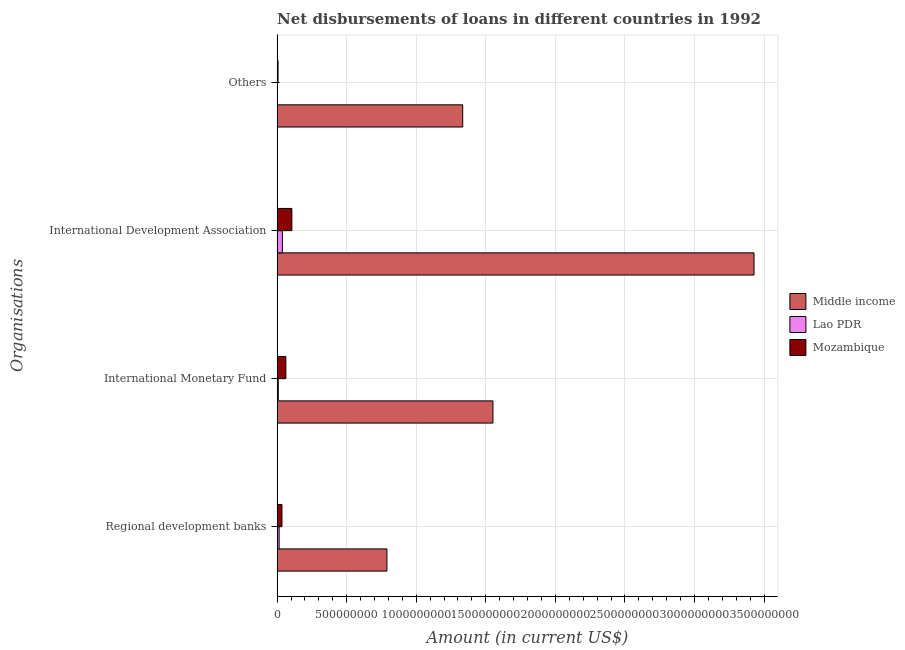How many different coloured bars are there?
Give a very brief answer. 3. How many groups of bars are there?
Make the answer very short. 4. Are the number of bars per tick equal to the number of legend labels?
Offer a terse response. No. Are the number of bars on each tick of the Y-axis equal?
Keep it short and to the point. No. How many bars are there on the 1st tick from the top?
Keep it short and to the point. 2. What is the label of the 2nd group of bars from the top?
Make the answer very short. International Development Association. What is the amount of loan disimbursed by other organisations in Lao PDR?
Offer a terse response. 0. Across all countries, what is the maximum amount of loan disimbursed by international monetary fund?
Ensure brevity in your answer.  1.55e+09. Across all countries, what is the minimum amount of loan disimbursed by international monetary fund?
Offer a terse response. 8.25e+06. What is the total amount of loan disimbursed by international development association in the graph?
Make the answer very short. 3.57e+09. What is the difference between the amount of loan disimbursed by international development association in Lao PDR and that in Mozambique?
Provide a short and direct response. -6.82e+07. What is the difference between the amount of loan disimbursed by regional development banks in Lao PDR and the amount of loan disimbursed by other organisations in Middle income?
Keep it short and to the point. -1.32e+09. What is the average amount of loan disimbursed by regional development banks per country?
Make the answer very short. 2.80e+08. What is the difference between the amount of loan disimbursed by regional development banks and amount of loan disimbursed by international development association in Lao PDR?
Your response must be concise. -2.32e+07. What is the ratio of the amount of loan disimbursed by other organisations in Middle income to that in Mozambique?
Offer a terse response. 203.04. What is the difference between the highest and the second highest amount of loan disimbursed by international development association?
Your response must be concise. 3.32e+09. What is the difference between the highest and the lowest amount of loan disimbursed by international monetary fund?
Offer a very short reply. 1.54e+09. Is it the case that in every country, the sum of the amount of loan disimbursed by regional development banks and amount of loan disimbursed by other organisations is greater than the sum of amount of loan disimbursed by international development association and amount of loan disimbursed by international monetary fund?
Provide a succinct answer. No. How many countries are there in the graph?
Make the answer very short. 3. Are the values on the major ticks of X-axis written in scientific E-notation?
Your answer should be very brief. No. Does the graph contain grids?
Provide a short and direct response. Yes. Where does the legend appear in the graph?
Provide a short and direct response. Center right. How many legend labels are there?
Your response must be concise. 3. How are the legend labels stacked?
Ensure brevity in your answer.  Vertical. What is the title of the graph?
Your answer should be compact. Net disbursements of loans in different countries in 1992. Does "Northern Mariana Islands" appear as one of the legend labels in the graph?
Provide a short and direct response. No. What is the label or title of the X-axis?
Ensure brevity in your answer.  Amount (in current US$). What is the label or title of the Y-axis?
Your answer should be compact. Organisations. What is the Amount (in current US$) of Middle income in Regional development banks?
Keep it short and to the point. 7.89e+08. What is the Amount (in current US$) in Lao PDR in Regional development banks?
Your answer should be compact. 1.45e+07. What is the Amount (in current US$) in Mozambique in Regional development banks?
Your answer should be compact. 3.48e+07. What is the Amount (in current US$) in Middle income in International Monetary Fund?
Your answer should be compact. 1.55e+09. What is the Amount (in current US$) of Lao PDR in International Monetary Fund?
Give a very brief answer. 8.25e+06. What is the Amount (in current US$) of Mozambique in International Monetary Fund?
Keep it short and to the point. 6.27e+07. What is the Amount (in current US$) of Middle income in International Development Association?
Give a very brief answer. 3.43e+09. What is the Amount (in current US$) in Lao PDR in International Development Association?
Provide a short and direct response. 3.77e+07. What is the Amount (in current US$) of Mozambique in International Development Association?
Your answer should be very brief. 1.06e+08. What is the Amount (in current US$) in Middle income in Others?
Provide a short and direct response. 1.33e+09. What is the Amount (in current US$) in Mozambique in Others?
Offer a terse response. 6.57e+06. Across all Organisations, what is the maximum Amount (in current US$) of Middle income?
Keep it short and to the point. 3.43e+09. Across all Organisations, what is the maximum Amount (in current US$) of Lao PDR?
Your response must be concise. 3.77e+07. Across all Organisations, what is the maximum Amount (in current US$) of Mozambique?
Your answer should be compact. 1.06e+08. Across all Organisations, what is the minimum Amount (in current US$) of Middle income?
Offer a terse response. 7.89e+08. Across all Organisations, what is the minimum Amount (in current US$) of Mozambique?
Ensure brevity in your answer.  6.57e+06. What is the total Amount (in current US$) of Middle income in the graph?
Give a very brief answer. 7.10e+09. What is the total Amount (in current US$) of Lao PDR in the graph?
Your response must be concise. 6.05e+07. What is the total Amount (in current US$) in Mozambique in the graph?
Your response must be concise. 2.10e+08. What is the difference between the Amount (in current US$) of Middle income in Regional development banks and that in International Monetary Fund?
Keep it short and to the point. -7.62e+08. What is the difference between the Amount (in current US$) in Lao PDR in Regional development banks and that in International Monetary Fund?
Offer a very short reply. 6.28e+06. What is the difference between the Amount (in current US$) in Mozambique in Regional development banks and that in International Monetary Fund?
Offer a terse response. -2.79e+07. What is the difference between the Amount (in current US$) of Middle income in Regional development banks and that in International Development Association?
Keep it short and to the point. -2.64e+09. What is the difference between the Amount (in current US$) in Lao PDR in Regional development banks and that in International Development Association?
Keep it short and to the point. -2.32e+07. What is the difference between the Amount (in current US$) in Mozambique in Regional development banks and that in International Development Association?
Ensure brevity in your answer.  -7.11e+07. What is the difference between the Amount (in current US$) of Middle income in Regional development banks and that in Others?
Ensure brevity in your answer.  -5.45e+08. What is the difference between the Amount (in current US$) in Mozambique in Regional development banks and that in Others?
Ensure brevity in your answer.  2.82e+07. What is the difference between the Amount (in current US$) of Middle income in International Monetary Fund and that in International Development Association?
Your answer should be very brief. -1.88e+09. What is the difference between the Amount (in current US$) of Lao PDR in International Monetary Fund and that in International Development Association?
Your answer should be very brief. -2.94e+07. What is the difference between the Amount (in current US$) in Mozambique in International Monetary Fund and that in International Development Association?
Your answer should be compact. -4.32e+07. What is the difference between the Amount (in current US$) of Middle income in International Monetary Fund and that in Others?
Your answer should be compact. 2.17e+08. What is the difference between the Amount (in current US$) of Mozambique in International Monetary Fund and that in Others?
Offer a very short reply. 5.62e+07. What is the difference between the Amount (in current US$) in Middle income in International Development Association and that in Others?
Provide a short and direct response. 2.09e+09. What is the difference between the Amount (in current US$) in Mozambique in International Development Association and that in Others?
Offer a terse response. 9.94e+07. What is the difference between the Amount (in current US$) of Middle income in Regional development banks and the Amount (in current US$) of Lao PDR in International Monetary Fund?
Make the answer very short. 7.81e+08. What is the difference between the Amount (in current US$) of Middle income in Regional development banks and the Amount (in current US$) of Mozambique in International Monetary Fund?
Your answer should be compact. 7.26e+08. What is the difference between the Amount (in current US$) of Lao PDR in Regional development banks and the Amount (in current US$) of Mozambique in International Monetary Fund?
Ensure brevity in your answer.  -4.82e+07. What is the difference between the Amount (in current US$) in Middle income in Regional development banks and the Amount (in current US$) in Lao PDR in International Development Association?
Your answer should be very brief. 7.51e+08. What is the difference between the Amount (in current US$) in Middle income in Regional development banks and the Amount (in current US$) in Mozambique in International Development Association?
Offer a very short reply. 6.83e+08. What is the difference between the Amount (in current US$) of Lao PDR in Regional development banks and the Amount (in current US$) of Mozambique in International Development Association?
Your response must be concise. -9.14e+07. What is the difference between the Amount (in current US$) of Middle income in Regional development banks and the Amount (in current US$) of Mozambique in Others?
Your answer should be compact. 7.83e+08. What is the difference between the Amount (in current US$) in Lao PDR in Regional development banks and the Amount (in current US$) in Mozambique in Others?
Provide a short and direct response. 7.96e+06. What is the difference between the Amount (in current US$) in Middle income in International Monetary Fund and the Amount (in current US$) in Lao PDR in International Development Association?
Your answer should be compact. 1.51e+09. What is the difference between the Amount (in current US$) in Middle income in International Monetary Fund and the Amount (in current US$) in Mozambique in International Development Association?
Provide a succinct answer. 1.45e+09. What is the difference between the Amount (in current US$) of Lao PDR in International Monetary Fund and the Amount (in current US$) of Mozambique in International Development Association?
Your answer should be very brief. -9.77e+07. What is the difference between the Amount (in current US$) of Middle income in International Monetary Fund and the Amount (in current US$) of Mozambique in Others?
Keep it short and to the point. 1.54e+09. What is the difference between the Amount (in current US$) of Lao PDR in International Monetary Fund and the Amount (in current US$) of Mozambique in Others?
Provide a succinct answer. 1.68e+06. What is the difference between the Amount (in current US$) of Middle income in International Development Association and the Amount (in current US$) of Mozambique in Others?
Offer a very short reply. 3.42e+09. What is the difference between the Amount (in current US$) in Lao PDR in International Development Association and the Amount (in current US$) in Mozambique in Others?
Your response must be concise. 3.11e+07. What is the average Amount (in current US$) in Middle income per Organisations?
Your answer should be compact. 1.78e+09. What is the average Amount (in current US$) of Lao PDR per Organisations?
Keep it short and to the point. 1.51e+07. What is the average Amount (in current US$) of Mozambique per Organisations?
Your answer should be very brief. 5.25e+07. What is the difference between the Amount (in current US$) of Middle income and Amount (in current US$) of Lao PDR in Regional development banks?
Your answer should be very brief. 7.75e+08. What is the difference between the Amount (in current US$) of Middle income and Amount (in current US$) of Mozambique in Regional development banks?
Your answer should be compact. 7.54e+08. What is the difference between the Amount (in current US$) in Lao PDR and Amount (in current US$) in Mozambique in Regional development banks?
Make the answer very short. -2.03e+07. What is the difference between the Amount (in current US$) in Middle income and Amount (in current US$) in Lao PDR in International Monetary Fund?
Your answer should be very brief. 1.54e+09. What is the difference between the Amount (in current US$) in Middle income and Amount (in current US$) in Mozambique in International Monetary Fund?
Make the answer very short. 1.49e+09. What is the difference between the Amount (in current US$) in Lao PDR and Amount (in current US$) in Mozambique in International Monetary Fund?
Offer a very short reply. -5.45e+07. What is the difference between the Amount (in current US$) of Middle income and Amount (in current US$) of Lao PDR in International Development Association?
Offer a very short reply. 3.39e+09. What is the difference between the Amount (in current US$) in Middle income and Amount (in current US$) in Mozambique in International Development Association?
Provide a short and direct response. 3.32e+09. What is the difference between the Amount (in current US$) of Lao PDR and Amount (in current US$) of Mozambique in International Development Association?
Your answer should be compact. -6.82e+07. What is the difference between the Amount (in current US$) of Middle income and Amount (in current US$) of Mozambique in Others?
Make the answer very short. 1.33e+09. What is the ratio of the Amount (in current US$) in Middle income in Regional development banks to that in International Monetary Fund?
Your answer should be very brief. 0.51. What is the ratio of the Amount (in current US$) of Lao PDR in Regional development banks to that in International Monetary Fund?
Ensure brevity in your answer.  1.76. What is the ratio of the Amount (in current US$) of Mozambique in Regional development banks to that in International Monetary Fund?
Make the answer very short. 0.55. What is the ratio of the Amount (in current US$) in Middle income in Regional development banks to that in International Development Association?
Ensure brevity in your answer.  0.23. What is the ratio of the Amount (in current US$) in Lao PDR in Regional development banks to that in International Development Association?
Provide a succinct answer. 0.39. What is the ratio of the Amount (in current US$) in Mozambique in Regional development banks to that in International Development Association?
Provide a succinct answer. 0.33. What is the ratio of the Amount (in current US$) of Middle income in Regional development banks to that in Others?
Offer a terse response. 0.59. What is the ratio of the Amount (in current US$) in Mozambique in Regional development banks to that in Others?
Keep it short and to the point. 5.3. What is the ratio of the Amount (in current US$) in Middle income in International Monetary Fund to that in International Development Association?
Your response must be concise. 0.45. What is the ratio of the Amount (in current US$) in Lao PDR in International Monetary Fund to that in International Development Association?
Provide a succinct answer. 0.22. What is the ratio of the Amount (in current US$) of Mozambique in International Monetary Fund to that in International Development Association?
Give a very brief answer. 0.59. What is the ratio of the Amount (in current US$) of Middle income in International Monetary Fund to that in Others?
Give a very brief answer. 1.16. What is the ratio of the Amount (in current US$) of Mozambique in International Monetary Fund to that in Others?
Your response must be concise. 9.55. What is the ratio of the Amount (in current US$) in Middle income in International Development Association to that in Others?
Your answer should be very brief. 2.57. What is the ratio of the Amount (in current US$) in Mozambique in International Development Association to that in Others?
Your answer should be compact. 16.12. What is the difference between the highest and the second highest Amount (in current US$) of Middle income?
Offer a very short reply. 1.88e+09. What is the difference between the highest and the second highest Amount (in current US$) in Lao PDR?
Give a very brief answer. 2.32e+07. What is the difference between the highest and the second highest Amount (in current US$) in Mozambique?
Your response must be concise. 4.32e+07. What is the difference between the highest and the lowest Amount (in current US$) in Middle income?
Keep it short and to the point. 2.64e+09. What is the difference between the highest and the lowest Amount (in current US$) in Lao PDR?
Offer a terse response. 3.77e+07. What is the difference between the highest and the lowest Amount (in current US$) of Mozambique?
Your answer should be very brief. 9.94e+07. 